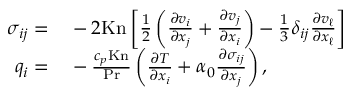<formula> <loc_0><loc_0><loc_500><loc_500>\begin{array} { r l } { \sigma _ { i j } = } & - 2 K n \left [ \frac { 1 } { 2 } \left ( \frac { \partial v _ { i } } { \partial x _ { j } } + \frac { \partial v _ { j } } { \partial x _ { i } } \right ) - \frac { 1 } { 3 } \delta _ { i j } \frac { \partial v _ { \ell } } { \partial x _ { \ell } } \right ] } \\ { q _ { i } = } & - \frac { c _ { p } K n } { P r } \left ( \frac { \partial T } { \partial x _ { i } } + \alpha _ { 0 } \frac { \partial \sigma _ { i j } } { \partial x _ { j } } \right ) , } \end{array}</formula> 